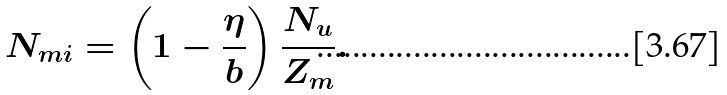Convert formula to latex. <formula><loc_0><loc_0><loc_500><loc_500>N _ { m i } = \left ( 1 - \frac { \eta } { b } \right ) \frac { N _ { u } } { Z _ { m } } .</formula> 